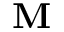Convert formula to latex. <formula><loc_0><loc_0><loc_500><loc_500>M</formula> 